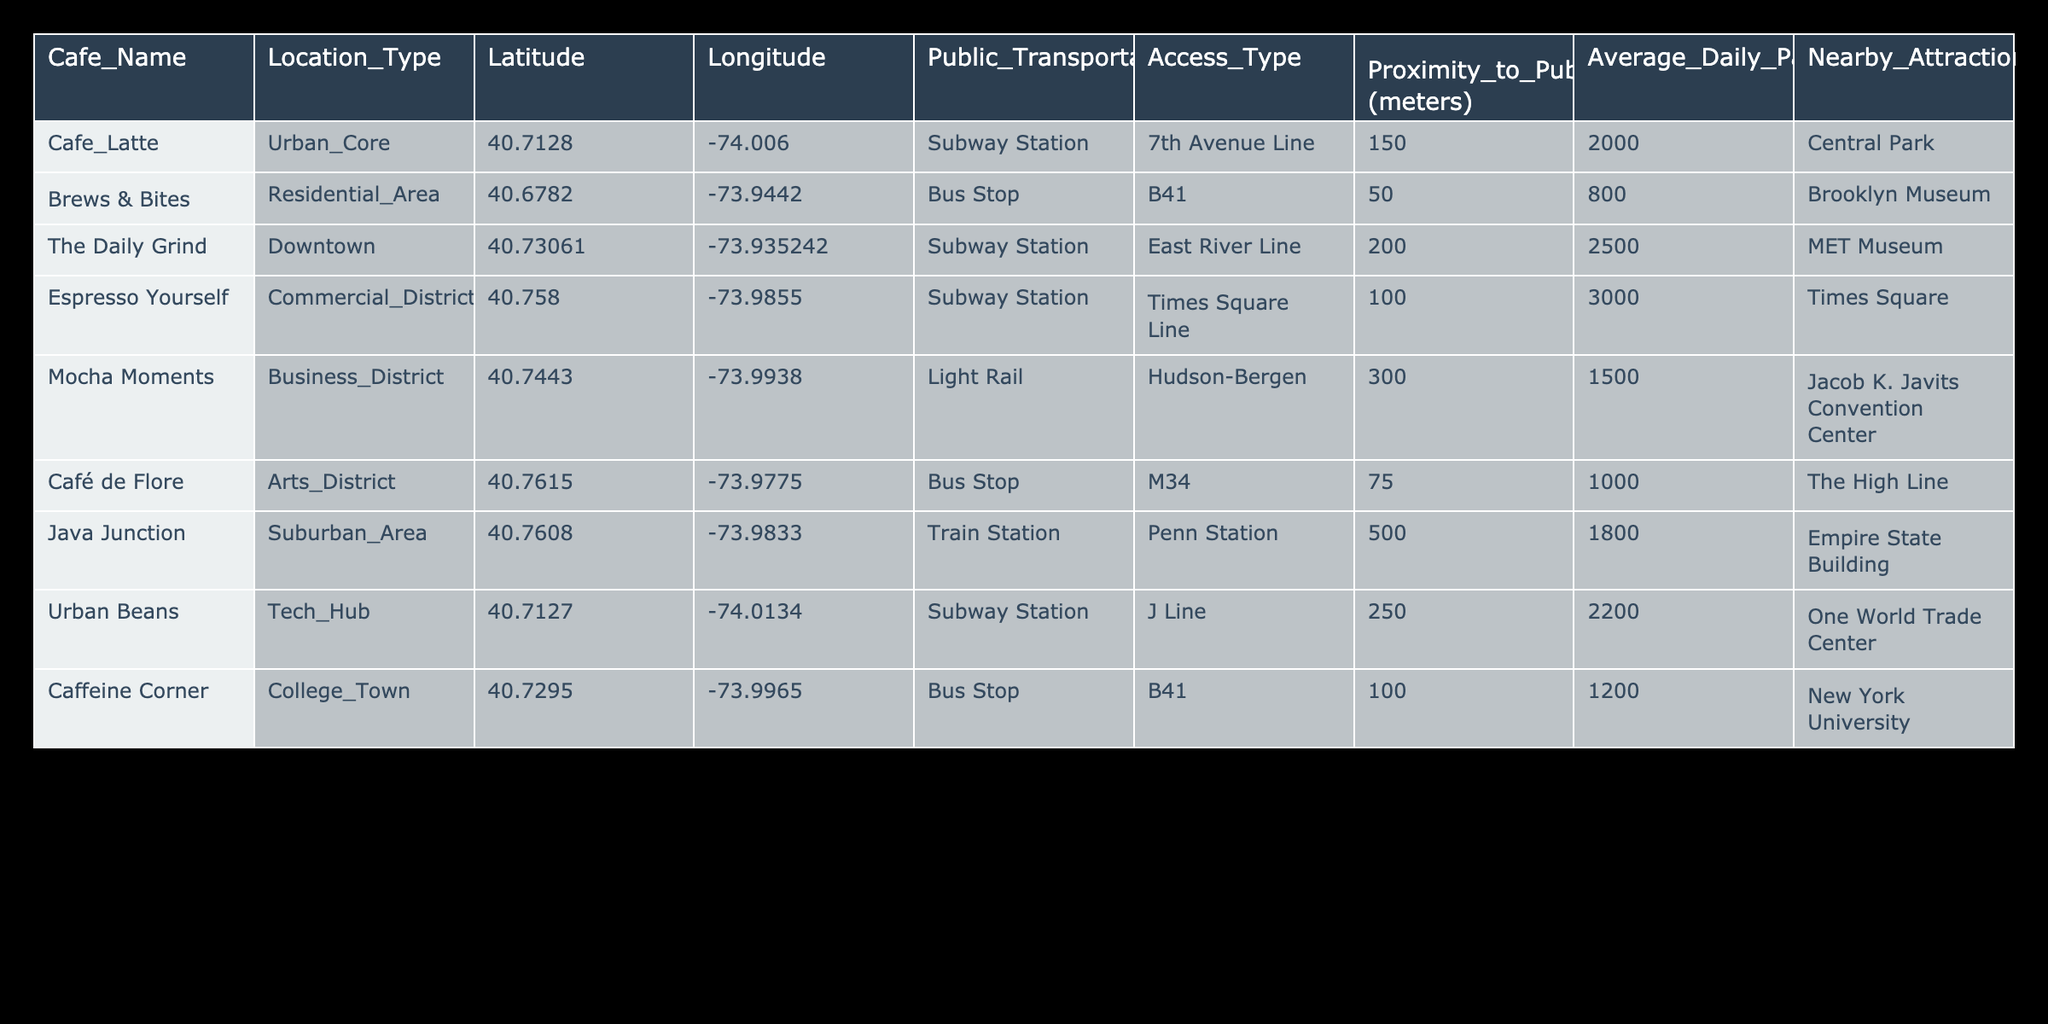What is the proximity of "Brews & Bites" to the nearest public transportation access point? According to the table, the proximity of "Brews & Bites" to the nearest public transport access point (Bus Stop, B41) is listed as 50 meters.
Answer: 50 meters Which cafe has the highest average daily passengers? From the table, "Espresso Yourself" has the highest average daily passengers at 3000, compared to other cafes.
Answer: Espresso Yourself Is "Café de Flore" located closer to public transport than "Java Junction"? "Café de Flore" is 75 meters from its bus stop, while "Java Junction" is 500 meters from its train station. Therefore, "Café de Flore" is closer to public transport.
Answer: Yes What is the total average daily passengers for cafes located near a Subway Station? The average daily passengers for cafes near a Subway Station are: "Cafe Latte" (2000) + "The Daily Grind" (2500) + "Espresso Yourself" (3000) + "Urban Beans" (2200) = 9700. The total is 9700.
Answer: 9700 Which cafe is located in the Business District and what is its access type? "Mocha Moments" is located in the Business District, and its access type is Light Rail.
Answer: Mocha Moments, Light Rail How many cafes are located closer than 100 meters to a public transportation access point? "Brews & Bites" (50 meters), "Café de Flore" (75 meters), and "Espresso Yourself" (100 meters) are all closer than 100 meters, resulting in a total of 3 cafes.
Answer: 3 Does "Java Junction" have a higher average daily passenger count than "Caffeine Corner"? "Java Junction" has 1800 average daily passengers while "Caffeine Corner" has 1200. Therefore, "Java Junction" has higher average daily passenger count.
Answer: Yes What is the average proximity of cafes located in the Urban Core? The only cafe in the Urban Core is "Cafe Latte," which is 150 meters from the subway station. Therefore, the average proximity for cafes in this area is also 150 meters.
Answer: 150 meters 